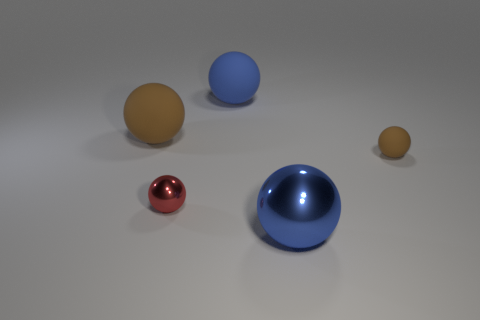How many cylinders are tiny brown things or metal objects?
Make the answer very short. 0. There is a metal sphere that is the same size as the blue matte object; what is its color?
Offer a very short reply. Blue. What number of big balls are both behind the tiny brown matte object and to the right of the red thing?
Your answer should be very brief. 1. What is the material of the small brown sphere?
Your answer should be very brief. Rubber. What number of objects are either large brown spheres or large objects?
Offer a very short reply. 3. Is the size of the brown matte ball that is on the left side of the small rubber sphere the same as the blue ball that is behind the tiny matte sphere?
Your answer should be very brief. Yes. How many other objects are the same size as the red object?
Provide a succinct answer. 1. How many objects are either tiny things behind the red ball or brown objects in front of the big brown matte sphere?
Your answer should be very brief. 1. Are the big brown object and the blue sphere that is in front of the large blue rubber thing made of the same material?
Offer a terse response. No. How many other objects are the same shape as the tiny matte thing?
Keep it short and to the point. 4. 